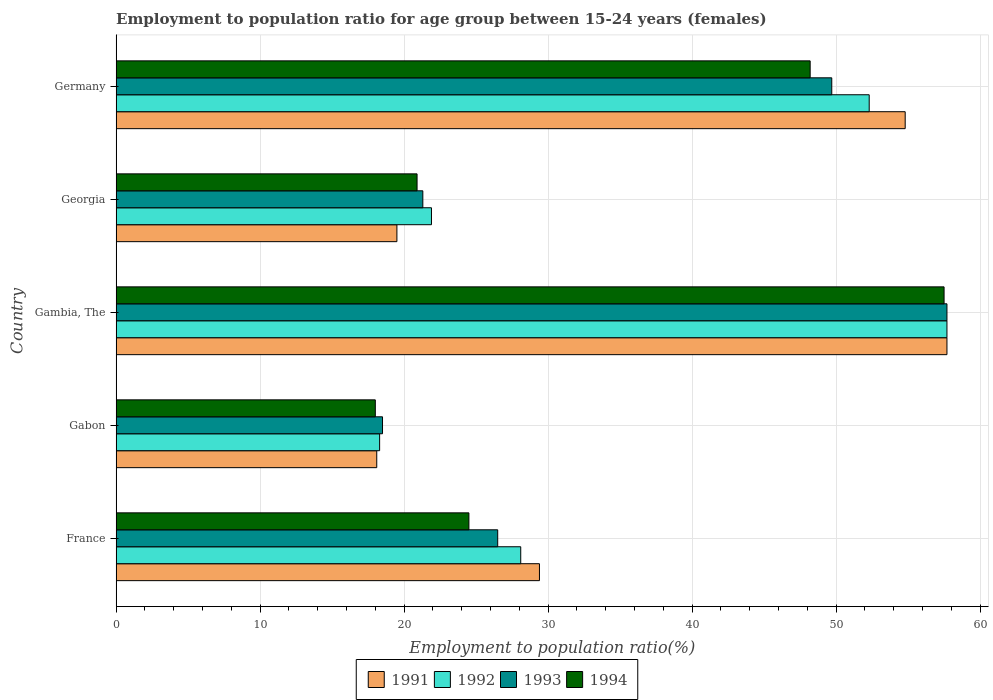Are the number of bars per tick equal to the number of legend labels?
Make the answer very short. Yes. Are the number of bars on each tick of the Y-axis equal?
Ensure brevity in your answer.  Yes. How many bars are there on the 3rd tick from the top?
Keep it short and to the point. 4. How many bars are there on the 5th tick from the bottom?
Your answer should be compact. 4. What is the label of the 1st group of bars from the top?
Make the answer very short. Germany. What is the employment to population ratio in 1994 in Georgia?
Make the answer very short. 20.9. Across all countries, what is the maximum employment to population ratio in 1991?
Provide a succinct answer. 57.7. Across all countries, what is the minimum employment to population ratio in 1993?
Make the answer very short. 18.5. In which country was the employment to population ratio in 1991 maximum?
Offer a very short reply. Gambia, The. In which country was the employment to population ratio in 1991 minimum?
Offer a very short reply. Gabon. What is the total employment to population ratio in 1994 in the graph?
Keep it short and to the point. 169.1. What is the difference between the employment to population ratio in 1991 in France and that in Georgia?
Make the answer very short. 9.9. What is the difference between the employment to population ratio in 1994 in France and the employment to population ratio in 1991 in Germany?
Ensure brevity in your answer.  -30.3. What is the average employment to population ratio in 1992 per country?
Offer a terse response. 35.66. What is the difference between the employment to population ratio in 1991 and employment to population ratio in 1993 in Georgia?
Make the answer very short. -1.8. In how many countries, is the employment to population ratio in 1992 greater than 34 %?
Your response must be concise. 2. What is the ratio of the employment to population ratio in 1994 in France to that in Gambia, The?
Your answer should be very brief. 0.43. Is the employment to population ratio in 1993 in France less than that in Georgia?
Keep it short and to the point. No. Is the difference between the employment to population ratio in 1991 in Gabon and Germany greater than the difference between the employment to population ratio in 1993 in Gabon and Germany?
Make the answer very short. No. What is the difference between the highest and the second highest employment to population ratio in 1991?
Offer a very short reply. 2.9. What is the difference between the highest and the lowest employment to population ratio in 1993?
Your answer should be compact. 39.2. In how many countries, is the employment to population ratio in 1993 greater than the average employment to population ratio in 1993 taken over all countries?
Keep it short and to the point. 2. Is the sum of the employment to population ratio in 1994 in Gambia, The and Georgia greater than the maximum employment to population ratio in 1992 across all countries?
Your response must be concise. Yes. Is it the case that in every country, the sum of the employment to population ratio in 1991 and employment to population ratio in 1992 is greater than the sum of employment to population ratio in 1993 and employment to population ratio in 1994?
Your answer should be very brief. No. What does the 4th bar from the top in Gambia, The represents?
Offer a very short reply. 1991. What does the 1st bar from the bottom in Gambia, The represents?
Your response must be concise. 1991. Is it the case that in every country, the sum of the employment to population ratio in 1991 and employment to population ratio in 1992 is greater than the employment to population ratio in 1993?
Keep it short and to the point. Yes. How many bars are there?
Your response must be concise. 20. What is the difference between two consecutive major ticks on the X-axis?
Make the answer very short. 10. Are the values on the major ticks of X-axis written in scientific E-notation?
Make the answer very short. No. Does the graph contain any zero values?
Provide a short and direct response. No. Does the graph contain grids?
Your response must be concise. Yes. Where does the legend appear in the graph?
Give a very brief answer. Bottom center. How many legend labels are there?
Make the answer very short. 4. How are the legend labels stacked?
Ensure brevity in your answer.  Horizontal. What is the title of the graph?
Make the answer very short. Employment to population ratio for age group between 15-24 years (females). Does "2015" appear as one of the legend labels in the graph?
Your answer should be compact. No. What is the Employment to population ratio(%) of 1991 in France?
Give a very brief answer. 29.4. What is the Employment to population ratio(%) of 1992 in France?
Make the answer very short. 28.1. What is the Employment to population ratio(%) in 1991 in Gabon?
Your answer should be compact. 18.1. What is the Employment to population ratio(%) of 1992 in Gabon?
Keep it short and to the point. 18.3. What is the Employment to population ratio(%) of 1991 in Gambia, The?
Offer a very short reply. 57.7. What is the Employment to population ratio(%) in 1992 in Gambia, The?
Keep it short and to the point. 57.7. What is the Employment to population ratio(%) of 1993 in Gambia, The?
Make the answer very short. 57.7. What is the Employment to population ratio(%) in 1994 in Gambia, The?
Your answer should be compact. 57.5. What is the Employment to population ratio(%) in 1992 in Georgia?
Your answer should be compact. 21.9. What is the Employment to population ratio(%) in 1993 in Georgia?
Keep it short and to the point. 21.3. What is the Employment to population ratio(%) in 1994 in Georgia?
Keep it short and to the point. 20.9. What is the Employment to population ratio(%) of 1991 in Germany?
Ensure brevity in your answer.  54.8. What is the Employment to population ratio(%) of 1992 in Germany?
Provide a short and direct response. 52.3. What is the Employment to population ratio(%) in 1993 in Germany?
Provide a short and direct response. 49.7. What is the Employment to population ratio(%) in 1994 in Germany?
Provide a succinct answer. 48.2. Across all countries, what is the maximum Employment to population ratio(%) of 1991?
Your answer should be very brief. 57.7. Across all countries, what is the maximum Employment to population ratio(%) in 1992?
Keep it short and to the point. 57.7. Across all countries, what is the maximum Employment to population ratio(%) in 1993?
Your answer should be compact. 57.7. Across all countries, what is the maximum Employment to population ratio(%) in 1994?
Provide a short and direct response. 57.5. Across all countries, what is the minimum Employment to population ratio(%) of 1991?
Give a very brief answer. 18.1. Across all countries, what is the minimum Employment to population ratio(%) in 1992?
Your answer should be very brief. 18.3. Across all countries, what is the minimum Employment to population ratio(%) of 1994?
Your answer should be very brief. 18. What is the total Employment to population ratio(%) of 1991 in the graph?
Provide a succinct answer. 179.5. What is the total Employment to population ratio(%) in 1992 in the graph?
Your response must be concise. 178.3. What is the total Employment to population ratio(%) of 1993 in the graph?
Your answer should be compact. 173.7. What is the total Employment to population ratio(%) in 1994 in the graph?
Offer a very short reply. 169.1. What is the difference between the Employment to population ratio(%) of 1991 in France and that in Gabon?
Your response must be concise. 11.3. What is the difference between the Employment to population ratio(%) of 1993 in France and that in Gabon?
Offer a terse response. 8. What is the difference between the Employment to population ratio(%) in 1991 in France and that in Gambia, The?
Keep it short and to the point. -28.3. What is the difference between the Employment to population ratio(%) in 1992 in France and that in Gambia, The?
Keep it short and to the point. -29.6. What is the difference between the Employment to population ratio(%) of 1993 in France and that in Gambia, The?
Ensure brevity in your answer.  -31.2. What is the difference between the Employment to population ratio(%) in 1994 in France and that in Gambia, The?
Offer a very short reply. -33. What is the difference between the Employment to population ratio(%) in 1992 in France and that in Georgia?
Make the answer very short. 6.2. What is the difference between the Employment to population ratio(%) of 1994 in France and that in Georgia?
Provide a succinct answer. 3.6. What is the difference between the Employment to population ratio(%) in 1991 in France and that in Germany?
Provide a short and direct response. -25.4. What is the difference between the Employment to population ratio(%) of 1992 in France and that in Germany?
Provide a succinct answer. -24.2. What is the difference between the Employment to population ratio(%) in 1993 in France and that in Germany?
Your response must be concise. -23.2. What is the difference between the Employment to population ratio(%) in 1994 in France and that in Germany?
Ensure brevity in your answer.  -23.7. What is the difference between the Employment to population ratio(%) of 1991 in Gabon and that in Gambia, The?
Keep it short and to the point. -39.6. What is the difference between the Employment to population ratio(%) in 1992 in Gabon and that in Gambia, The?
Your answer should be compact. -39.4. What is the difference between the Employment to population ratio(%) in 1993 in Gabon and that in Gambia, The?
Make the answer very short. -39.2. What is the difference between the Employment to population ratio(%) of 1994 in Gabon and that in Gambia, The?
Make the answer very short. -39.5. What is the difference between the Employment to population ratio(%) of 1994 in Gabon and that in Georgia?
Provide a succinct answer. -2.9. What is the difference between the Employment to population ratio(%) in 1991 in Gabon and that in Germany?
Ensure brevity in your answer.  -36.7. What is the difference between the Employment to population ratio(%) of 1992 in Gabon and that in Germany?
Provide a succinct answer. -34. What is the difference between the Employment to population ratio(%) of 1993 in Gabon and that in Germany?
Offer a very short reply. -31.2. What is the difference between the Employment to population ratio(%) of 1994 in Gabon and that in Germany?
Your response must be concise. -30.2. What is the difference between the Employment to population ratio(%) of 1991 in Gambia, The and that in Georgia?
Offer a very short reply. 38.2. What is the difference between the Employment to population ratio(%) of 1992 in Gambia, The and that in Georgia?
Your answer should be very brief. 35.8. What is the difference between the Employment to population ratio(%) in 1993 in Gambia, The and that in Georgia?
Provide a succinct answer. 36.4. What is the difference between the Employment to population ratio(%) of 1994 in Gambia, The and that in Georgia?
Give a very brief answer. 36.6. What is the difference between the Employment to population ratio(%) in 1994 in Gambia, The and that in Germany?
Provide a succinct answer. 9.3. What is the difference between the Employment to population ratio(%) of 1991 in Georgia and that in Germany?
Provide a short and direct response. -35.3. What is the difference between the Employment to population ratio(%) in 1992 in Georgia and that in Germany?
Ensure brevity in your answer.  -30.4. What is the difference between the Employment to population ratio(%) of 1993 in Georgia and that in Germany?
Offer a terse response. -28.4. What is the difference between the Employment to population ratio(%) in 1994 in Georgia and that in Germany?
Offer a terse response. -27.3. What is the difference between the Employment to population ratio(%) of 1991 in France and the Employment to population ratio(%) of 1992 in Gabon?
Your answer should be very brief. 11.1. What is the difference between the Employment to population ratio(%) in 1991 in France and the Employment to population ratio(%) in 1994 in Gabon?
Make the answer very short. 11.4. What is the difference between the Employment to population ratio(%) of 1992 in France and the Employment to population ratio(%) of 1993 in Gabon?
Make the answer very short. 9.6. What is the difference between the Employment to population ratio(%) in 1992 in France and the Employment to population ratio(%) in 1994 in Gabon?
Ensure brevity in your answer.  10.1. What is the difference between the Employment to population ratio(%) of 1993 in France and the Employment to population ratio(%) of 1994 in Gabon?
Your answer should be compact. 8.5. What is the difference between the Employment to population ratio(%) of 1991 in France and the Employment to population ratio(%) of 1992 in Gambia, The?
Offer a very short reply. -28.3. What is the difference between the Employment to population ratio(%) of 1991 in France and the Employment to population ratio(%) of 1993 in Gambia, The?
Offer a terse response. -28.3. What is the difference between the Employment to population ratio(%) in 1991 in France and the Employment to population ratio(%) in 1994 in Gambia, The?
Provide a succinct answer. -28.1. What is the difference between the Employment to population ratio(%) in 1992 in France and the Employment to population ratio(%) in 1993 in Gambia, The?
Ensure brevity in your answer.  -29.6. What is the difference between the Employment to population ratio(%) of 1992 in France and the Employment to population ratio(%) of 1994 in Gambia, The?
Your answer should be compact. -29.4. What is the difference between the Employment to population ratio(%) in 1993 in France and the Employment to population ratio(%) in 1994 in Gambia, The?
Make the answer very short. -31. What is the difference between the Employment to population ratio(%) of 1991 in France and the Employment to population ratio(%) of 1993 in Georgia?
Give a very brief answer. 8.1. What is the difference between the Employment to population ratio(%) in 1991 in France and the Employment to population ratio(%) in 1994 in Georgia?
Your answer should be compact. 8.5. What is the difference between the Employment to population ratio(%) of 1992 in France and the Employment to population ratio(%) of 1993 in Georgia?
Offer a terse response. 6.8. What is the difference between the Employment to population ratio(%) of 1992 in France and the Employment to population ratio(%) of 1994 in Georgia?
Offer a very short reply. 7.2. What is the difference between the Employment to population ratio(%) in 1991 in France and the Employment to population ratio(%) in 1992 in Germany?
Your answer should be very brief. -22.9. What is the difference between the Employment to population ratio(%) of 1991 in France and the Employment to population ratio(%) of 1993 in Germany?
Provide a succinct answer. -20.3. What is the difference between the Employment to population ratio(%) of 1991 in France and the Employment to population ratio(%) of 1994 in Germany?
Your answer should be very brief. -18.8. What is the difference between the Employment to population ratio(%) in 1992 in France and the Employment to population ratio(%) in 1993 in Germany?
Your answer should be very brief. -21.6. What is the difference between the Employment to population ratio(%) of 1992 in France and the Employment to population ratio(%) of 1994 in Germany?
Give a very brief answer. -20.1. What is the difference between the Employment to population ratio(%) of 1993 in France and the Employment to population ratio(%) of 1994 in Germany?
Give a very brief answer. -21.7. What is the difference between the Employment to population ratio(%) of 1991 in Gabon and the Employment to population ratio(%) of 1992 in Gambia, The?
Provide a short and direct response. -39.6. What is the difference between the Employment to population ratio(%) of 1991 in Gabon and the Employment to population ratio(%) of 1993 in Gambia, The?
Your answer should be very brief. -39.6. What is the difference between the Employment to population ratio(%) of 1991 in Gabon and the Employment to population ratio(%) of 1994 in Gambia, The?
Give a very brief answer. -39.4. What is the difference between the Employment to population ratio(%) in 1992 in Gabon and the Employment to population ratio(%) in 1993 in Gambia, The?
Offer a very short reply. -39.4. What is the difference between the Employment to population ratio(%) in 1992 in Gabon and the Employment to population ratio(%) in 1994 in Gambia, The?
Provide a short and direct response. -39.2. What is the difference between the Employment to population ratio(%) of 1993 in Gabon and the Employment to population ratio(%) of 1994 in Gambia, The?
Offer a very short reply. -39. What is the difference between the Employment to population ratio(%) of 1991 in Gabon and the Employment to population ratio(%) of 1992 in Georgia?
Offer a very short reply. -3.8. What is the difference between the Employment to population ratio(%) in 1991 in Gabon and the Employment to population ratio(%) in 1993 in Georgia?
Your response must be concise. -3.2. What is the difference between the Employment to population ratio(%) of 1991 in Gabon and the Employment to population ratio(%) of 1994 in Georgia?
Your answer should be compact. -2.8. What is the difference between the Employment to population ratio(%) in 1992 in Gabon and the Employment to population ratio(%) in 1993 in Georgia?
Your answer should be compact. -3. What is the difference between the Employment to population ratio(%) in 1992 in Gabon and the Employment to population ratio(%) in 1994 in Georgia?
Give a very brief answer. -2.6. What is the difference between the Employment to population ratio(%) in 1993 in Gabon and the Employment to population ratio(%) in 1994 in Georgia?
Ensure brevity in your answer.  -2.4. What is the difference between the Employment to population ratio(%) in 1991 in Gabon and the Employment to population ratio(%) in 1992 in Germany?
Your answer should be compact. -34.2. What is the difference between the Employment to population ratio(%) of 1991 in Gabon and the Employment to population ratio(%) of 1993 in Germany?
Keep it short and to the point. -31.6. What is the difference between the Employment to population ratio(%) in 1991 in Gabon and the Employment to population ratio(%) in 1994 in Germany?
Provide a succinct answer. -30.1. What is the difference between the Employment to population ratio(%) of 1992 in Gabon and the Employment to population ratio(%) of 1993 in Germany?
Your answer should be compact. -31.4. What is the difference between the Employment to population ratio(%) of 1992 in Gabon and the Employment to population ratio(%) of 1994 in Germany?
Keep it short and to the point. -29.9. What is the difference between the Employment to population ratio(%) of 1993 in Gabon and the Employment to population ratio(%) of 1994 in Germany?
Your answer should be compact. -29.7. What is the difference between the Employment to population ratio(%) in 1991 in Gambia, The and the Employment to population ratio(%) in 1992 in Georgia?
Your answer should be compact. 35.8. What is the difference between the Employment to population ratio(%) of 1991 in Gambia, The and the Employment to population ratio(%) of 1993 in Georgia?
Keep it short and to the point. 36.4. What is the difference between the Employment to population ratio(%) in 1991 in Gambia, The and the Employment to population ratio(%) in 1994 in Georgia?
Give a very brief answer. 36.8. What is the difference between the Employment to population ratio(%) of 1992 in Gambia, The and the Employment to population ratio(%) of 1993 in Georgia?
Make the answer very short. 36.4. What is the difference between the Employment to population ratio(%) in 1992 in Gambia, The and the Employment to population ratio(%) in 1994 in Georgia?
Provide a short and direct response. 36.8. What is the difference between the Employment to population ratio(%) of 1993 in Gambia, The and the Employment to population ratio(%) of 1994 in Georgia?
Give a very brief answer. 36.8. What is the difference between the Employment to population ratio(%) of 1991 in Gambia, The and the Employment to population ratio(%) of 1993 in Germany?
Provide a succinct answer. 8. What is the difference between the Employment to population ratio(%) of 1991 in Gambia, The and the Employment to population ratio(%) of 1994 in Germany?
Offer a very short reply. 9.5. What is the difference between the Employment to population ratio(%) in 1992 in Gambia, The and the Employment to population ratio(%) in 1993 in Germany?
Provide a short and direct response. 8. What is the difference between the Employment to population ratio(%) of 1991 in Georgia and the Employment to population ratio(%) of 1992 in Germany?
Make the answer very short. -32.8. What is the difference between the Employment to population ratio(%) of 1991 in Georgia and the Employment to population ratio(%) of 1993 in Germany?
Your answer should be very brief. -30.2. What is the difference between the Employment to population ratio(%) of 1991 in Georgia and the Employment to population ratio(%) of 1994 in Germany?
Make the answer very short. -28.7. What is the difference between the Employment to population ratio(%) of 1992 in Georgia and the Employment to population ratio(%) of 1993 in Germany?
Offer a very short reply. -27.8. What is the difference between the Employment to population ratio(%) in 1992 in Georgia and the Employment to population ratio(%) in 1994 in Germany?
Offer a terse response. -26.3. What is the difference between the Employment to population ratio(%) of 1993 in Georgia and the Employment to population ratio(%) of 1994 in Germany?
Your answer should be compact. -26.9. What is the average Employment to population ratio(%) of 1991 per country?
Offer a terse response. 35.9. What is the average Employment to population ratio(%) in 1992 per country?
Your answer should be very brief. 35.66. What is the average Employment to population ratio(%) of 1993 per country?
Provide a short and direct response. 34.74. What is the average Employment to population ratio(%) in 1994 per country?
Keep it short and to the point. 33.82. What is the difference between the Employment to population ratio(%) of 1991 and Employment to population ratio(%) of 1992 in France?
Your answer should be very brief. 1.3. What is the difference between the Employment to population ratio(%) of 1991 and Employment to population ratio(%) of 1994 in France?
Your answer should be compact. 4.9. What is the difference between the Employment to population ratio(%) of 1992 and Employment to population ratio(%) of 1993 in France?
Give a very brief answer. 1.6. What is the difference between the Employment to population ratio(%) in 1991 and Employment to population ratio(%) in 1993 in Gabon?
Make the answer very short. -0.4. What is the difference between the Employment to population ratio(%) of 1991 and Employment to population ratio(%) of 1994 in Gabon?
Offer a very short reply. 0.1. What is the difference between the Employment to population ratio(%) in 1992 and Employment to population ratio(%) in 1994 in Gabon?
Your answer should be compact. 0.3. What is the difference between the Employment to population ratio(%) of 1991 and Employment to population ratio(%) of 1992 in Gambia, The?
Offer a terse response. 0. What is the difference between the Employment to population ratio(%) in 1991 and Employment to population ratio(%) in 1993 in Gambia, The?
Your response must be concise. 0. What is the difference between the Employment to population ratio(%) of 1991 and Employment to population ratio(%) of 1994 in Gambia, The?
Give a very brief answer. 0.2. What is the difference between the Employment to population ratio(%) of 1993 and Employment to population ratio(%) of 1994 in Gambia, The?
Keep it short and to the point. 0.2. What is the difference between the Employment to population ratio(%) in 1991 and Employment to population ratio(%) in 1992 in Georgia?
Your answer should be very brief. -2.4. What is the difference between the Employment to population ratio(%) in 1991 and Employment to population ratio(%) in 1993 in Georgia?
Your answer should be very brief. -1.8. What is the difference between the Employment to population ratio(%) in 1991 and Employment to population ratio(%) in 1994 in Georgia?
Offer a very short reply. -1.4. What is the difference between the Employment to population ratio(%) in 1992 and Employment to population ratio(%) in 1993 in Georgia?
Keep it short and to the point. 0.6. What is the difference between the Employment to population ratio(%) in 1993 and Employment to population ratio(%) in 1994 in Georgia?
Your answer should be very brief. 0.4. What is the difference between the Employment to population ratio(%) in 1991 and Employment to population ratio(%) in 1992 in Germany?
Ensure brevity in your answer.  2.5. What is the difference between the Employment to population ratio(%) in 1991 and Employment to population ratio(%) in 1993 in Germany?
Your answer should be very brief. 5.1. What is the difference between the Employment to population ratio(%) in 1992 and Employment to population ratio(%) in 1993 in Germany?
Your response must be concise. 2.6. What is the difference between the Employment to population ratio(%) of 1992 and Employment to population ratio(%) of 1994 in Germany?
Your answer should be compact. 4.1. What is the difference between the Employment to population ratio(%) in 1993 and Employment to population ratio(%) in 1994 in Germany?
Provide a succinct answer. 1.5. What is the ratio of the Employment to population ratio(%) of 1991 in France to that in Gabon?
Offer a terse response. 1.62. What is the ratio of the Employment to population ratio(%) of 1992 in France to that in Gabon?
Keep it short and to the point. 1.54. What is the ratio of the Employment to population ratio(%) in 1993 in France to that in Gabon?
Make the answer very short. 1.43. What is the ratio of the Employment to population ratio(%) of 1994 in France to that in Gabon?
Provide a succinct answer. 1.36. What is the ratio of the Employment to population ratio(%) in 1991 in France to that in Gambia, The?
Keep it short and to the point. 0.51. What is the ratio of the Employment to population ratio(%) of 1992 in France to that in Gambia, The?
Offer a very short reply. 0.49. What is the ratio of the Employment to population ratio(%) in 1993 in France to that in Gambia, The?
Your response must be concise. 0.46. What is the ratio of the Employment to population ratio(%) of 1994 in France to that in Gambia, The?
Your answer should be compact. 0.43. What is the ratio of the Employment to population ratio(%) of 1991 in France to that in Georgia?
Make the answer very short. 1.51. What is the ratio of the Employment to population ratio(%) in 1992 in France to that in Georgia?
Give a very brief answer. 1.28. What is the ratio of the Employment to population ratio(%) of 1993 in France to that in Georgia?
Offer a terse response. 1.24. What is the ratio of the Employment to population ratio(%) of 1994 in France to that in Georgia?
Offer a terse response. 1.17. What is the ratio of the Employment to population ratio(%) in 1991 in France to that in Germany?
Keep it short and to the point. 0.54. What is the ratio of the Employment to population ratio(%) of 1992 in France to that in Germany?
Offer a terse response. 0.54. What is the ratio of the Employment to population ratio(%) of 1993 in France to that in Germany?
Offer a very short reply. 0.53. What is the ratio of the Employment to population ratio(%) of 1994 in France to that in Germany?
Give a very brief answer. 0.51. What is the ratio of the Employment to population ratio(%) in 1991 in Gabon to that in Gambia, The?
Your answer should be compact. 0.31. What is the ratio of the Employment to population ratio(%) of 1992 in Gabon to that in Gambia, The?
Your response must be concise. 0.32. What is the ratio of the Employment to population ratio(%) of 1993 in Gabon to that in Gambia, The?
Keep it short and to the point. 0.32. What is the ratio of the Employment to population ratio(%) of 1994 in Gabon to that in Gambia, The?
Your answer should be very brief. 0.31. What is the ratio of the Employment to population ratio(%) of 1991 in Gabon to that in Georgia?
Offer a terse response. 0.93. What is the ratio of the Employment to population ratio(%) of 1992 in Gabon to that in Georgia?
Provide a short and direct response. 0.84. What is the ratio of the Employment to population ratio(%) of 1993 in Gabon to that in Georgia?
Offer a terse response. 0.87. What is the ratio of the Employment to population ratio(%) in 1994 in Gabon to that in Georgia?
Offer a very short reply. 0.86. What is the ratio of the Employment to population ratio(%) of 1991 in Gabon to that in Germany?
Keep it short and to the point. 0.33. What is the ratio of the Employment to population ratio(%) in 1992 in Gabon to that in Germany?
Give a very brief answer. 0.35. What is the ratio of the Employment to population ratio(%) of 1993 in Gabon to that in Germany?
Offer a terse response. 0.37. What is the ratio of the Employment to population ratio(%) in 1994 in Gabon to that in Germany?
Your response must be concise. 0.37. What is the ratio of the Employment to population ratio(%) of 1991 in Gambia, The to that in Georgia?
Make the answer very short. 2.96. What is the ratio of the Employment to population ratio(%) in 1992 in Gambia, The to that in Georgia?
Ensure brevity in your answer.  2.63. What is the ratio of the Employment to population ratio(%) of 1993 in Gambia, The to that in Georgia?
Provide a short and direct response. 2.71. What is the ratio of the Employment to population ratio(%) in 1994 in Gambia, The to that in Georgia?
Offer a terse response. 2.75. What is the ratio of the Employment to population ratio(%) in 1991 in Gambia, The to that in Germany?
Make the answer very short. 1.05. What is the ratio of the Employment to population ratio(%) in 1992 in Gambia, The to that in Germany?
Provide a short and direct response. 1.1. What is the ratio of the Employment to population ratio(%) of 1993 in Gambia, The to that in Germany?
Give a very brief answer. 1.16. What is the ratio of the Employment to population ratio(%) in 1994 in Gambia, The to that in Germany?
Give a very brief answer. 1.19. What is the ratio of the Employment to population ratio(%) of 1991 in Georgia to that in Germany?
Your answer should be compact. 0.36. What is the ratio of the Employment to population ratio(%) in 1992 in Georgia to that in Germany?
Your answer should be compact. 0.42. What is the ratio of the Employment to population ratio(%) in 1993 in Georgia to that in Germany?
Provide a short and direct response. 0.43. What is the ratio of the Employment to population ratio(%) in 1994 in Georgia to that in Germany?
Offer a terse response. 0.43. What is the difference between the highest and the second highest Employment to population ratio(%) in 1993?
Ensure brevity in your answer.  8. What is the difference between the highest and the second highest Employment to population ratio(%) of 1994?
Offer a very short reply. 9.3. What is the difference between the highest and the lowest Employment to population ratio(%) of 1991?
Your answer should be very brief. 39.6. What is the difference between the highest and the lowest Employment to population ratio(%) in 1992?
Your answer should be very brief. 39.4. What is the difference between the highest and the lowest Employment to population ratio(%) in 1993?
Ensure brevity in your answer.  39.2. What is the difference between the highest and the lowest Employment to population ratio(%) in 1994?
Ensure brevity in your answer.  39.5. 